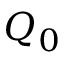<formula> <loc_0><loc_0><loc_500><loc_500>Q _ { 0 }</formula> 